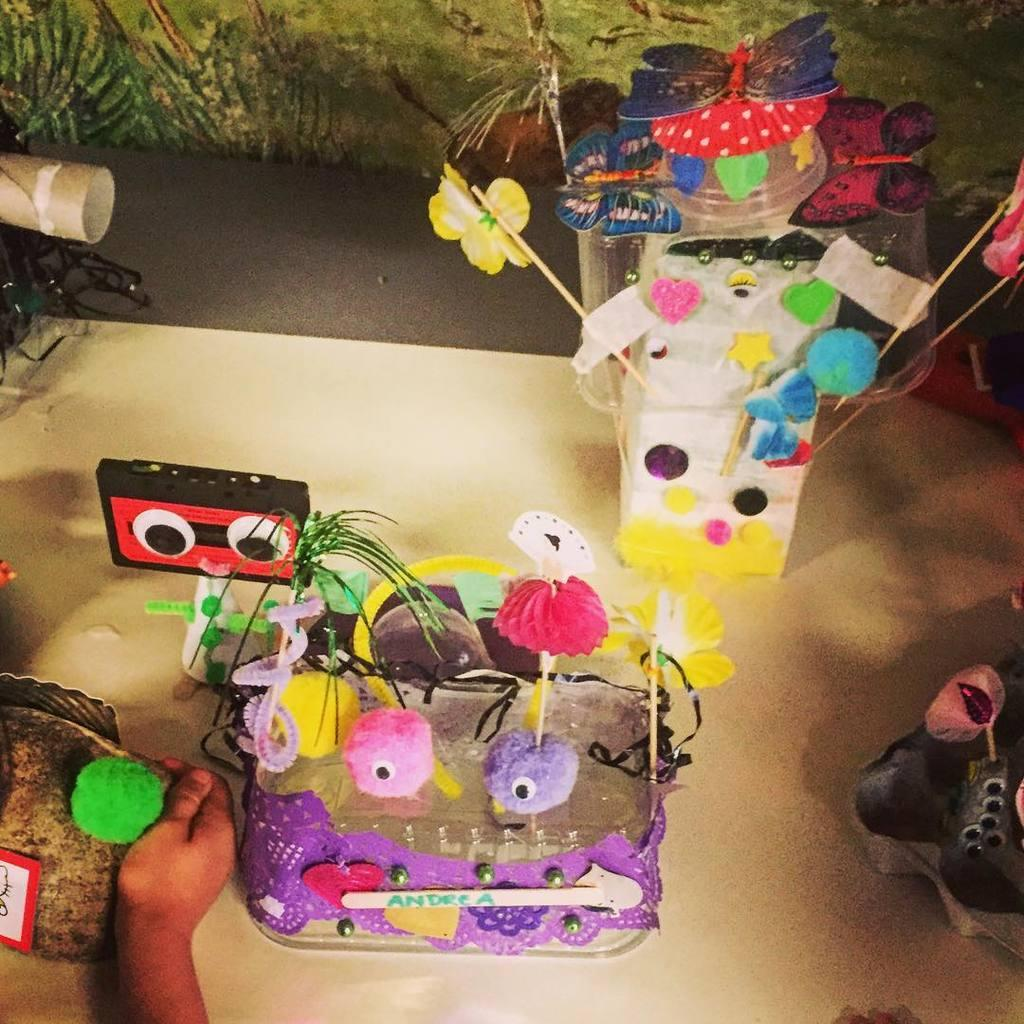What objects can be seen on the surface in the image? There are toys on the surface in the image. Can you describe any other elements in the image? The hand of a person is visible on the left side of the image. What type of chin can be seen on the sofa in the image? There is no chin or sofa present in the image. Are there any worms crawling on the toys in the image? There are no worms present in the image; only toys and a hand are visible. 